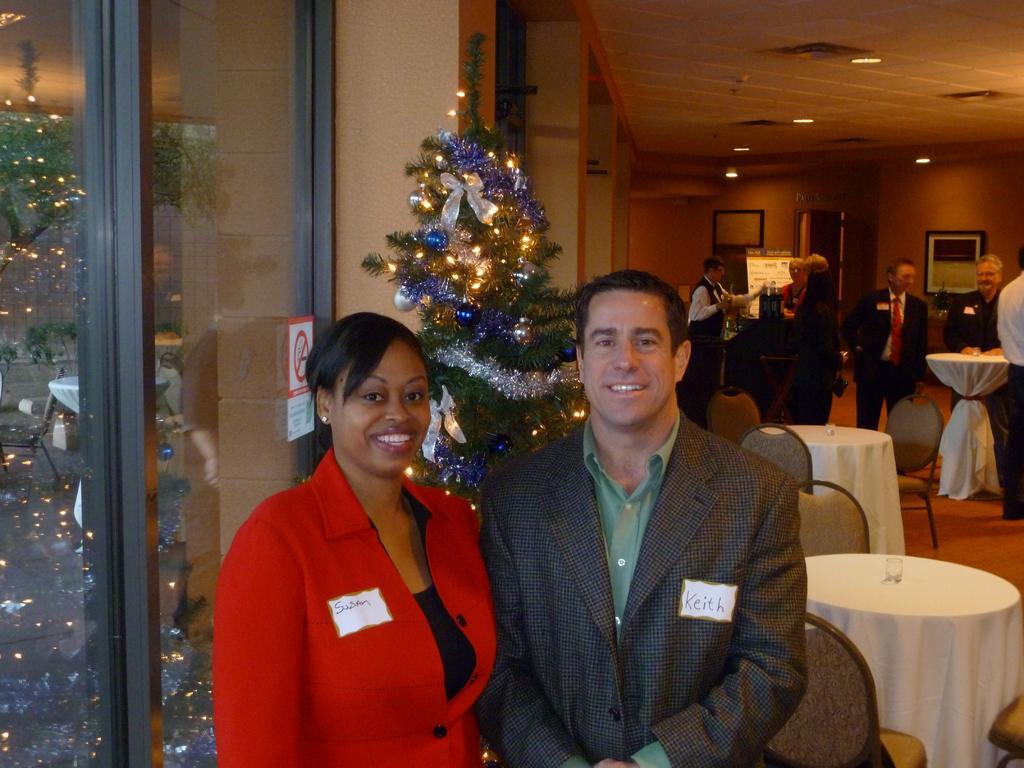In one or two sentences, can you explain what this image depicts? In this picture there is a woman and a man, standing. Both of them were smiling. In the background, there is a tree which was decorated with lights. There are some tables and chairs behind them. Some of them was standing in the background. We can observe some photo frames attached to the walls here. 